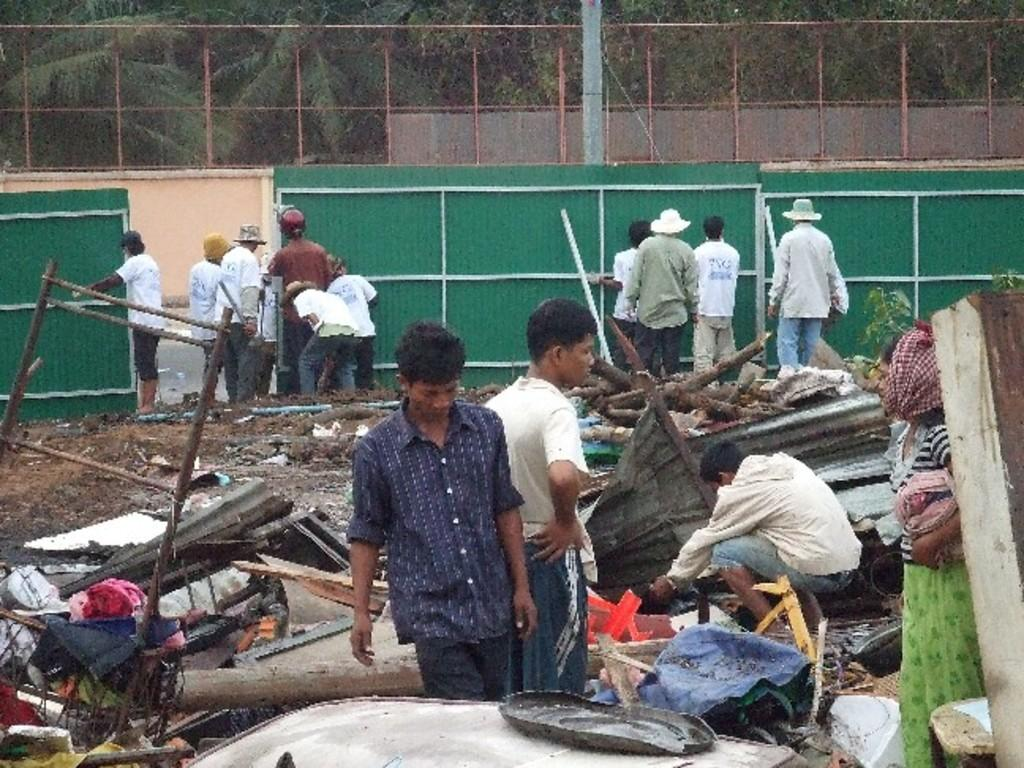Who or what can be seen in the image? There are people and objects in the image. What type of structure is present in the image? There is fencing in the image. What natural elements can be seen in the image? There are trees in the image. What type of cloth is being used by the minister in the image? There is no minister or cloth present in the image. How many women are visible in the image? The provided facts do not mention the gender of the people in the image, so it cannot be determined if there are any women present. 